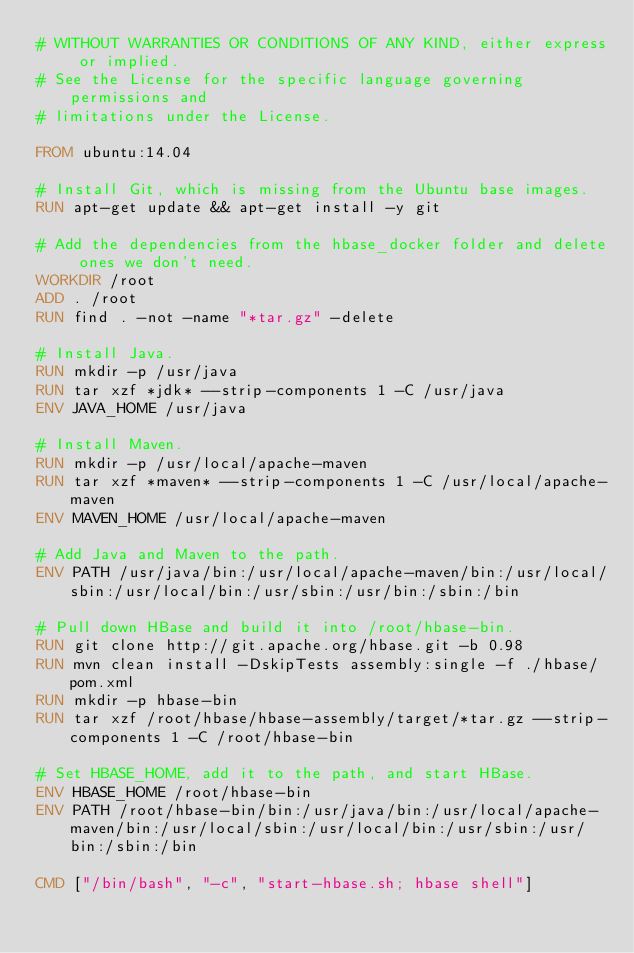Convert code to text. <code><loc_0><loc_0><loc_500><loc_500><_Dockerfile_># WITHOUT WARRANTIES OR CONDITIONS OF ANY KIND, either express or implied.
# See the License for the specific language governing permissions and
# limitations under the License.

FROM ubuntu:14.04

# Install Git, which is missing from the Ubuntu base images.
RUN apt-get update && apt-get install -y git

# Add the dependencies from the hbase_docker folder and delete ones we don't need.
WORKDIR /root
ADD . /root
RUN find . -not -name "*tar.gz" -delete

# Install Java.
RUN mkdir -p /usr/java
RUN tar xzf *jdk* --strip-components 1 -C /usr/java
ENV JAVA_HOME /usr/java

# Install Maven.
RUN mkdir -p /usr/local/apache-maven
RUN tar xzf *maven* --strip-components 1 -C /usr/local/apache-maven
ENV MAVEN_HOME /usr/local/apache-maven

# Add Java and Maven to the path.
ENV PATH /usr/java/bin:/usr/local/apache-maven/bin:/usr/local/sbin:/usr/local/bin:/usr/sbin:/usr/bin:/sbin:/bin

# Pull down HBase and build it into /root/hbase-bin.
RUN git clone http://git.apache.org/hbase.git -b 0.98
RUN mvn clean install -DskipTests assembly:single -f ./hbase/pom.xml
RUN mkdir -p hbase-bin
RUN tar xzf /root/hbase/hbase-assembly/target/*tar.gz --strip-components 1 -C /root/hbase-bin

# Set HBASE_HOME, add it to the path, and start HBase.
ENV HBASE_HOME /root/hbase-bin
ENV PATH /root/hbase-bin/bin:/usr/java/bin:/usr/local/apache-maven/bin:/usr/local/sbin:/usr/local/bin:/usr/sbin:/usr/bin:/sbin:/bin

CMD ["/bin/bash", "-c", "start-hbase.sh; hbase shell"]
</code> 